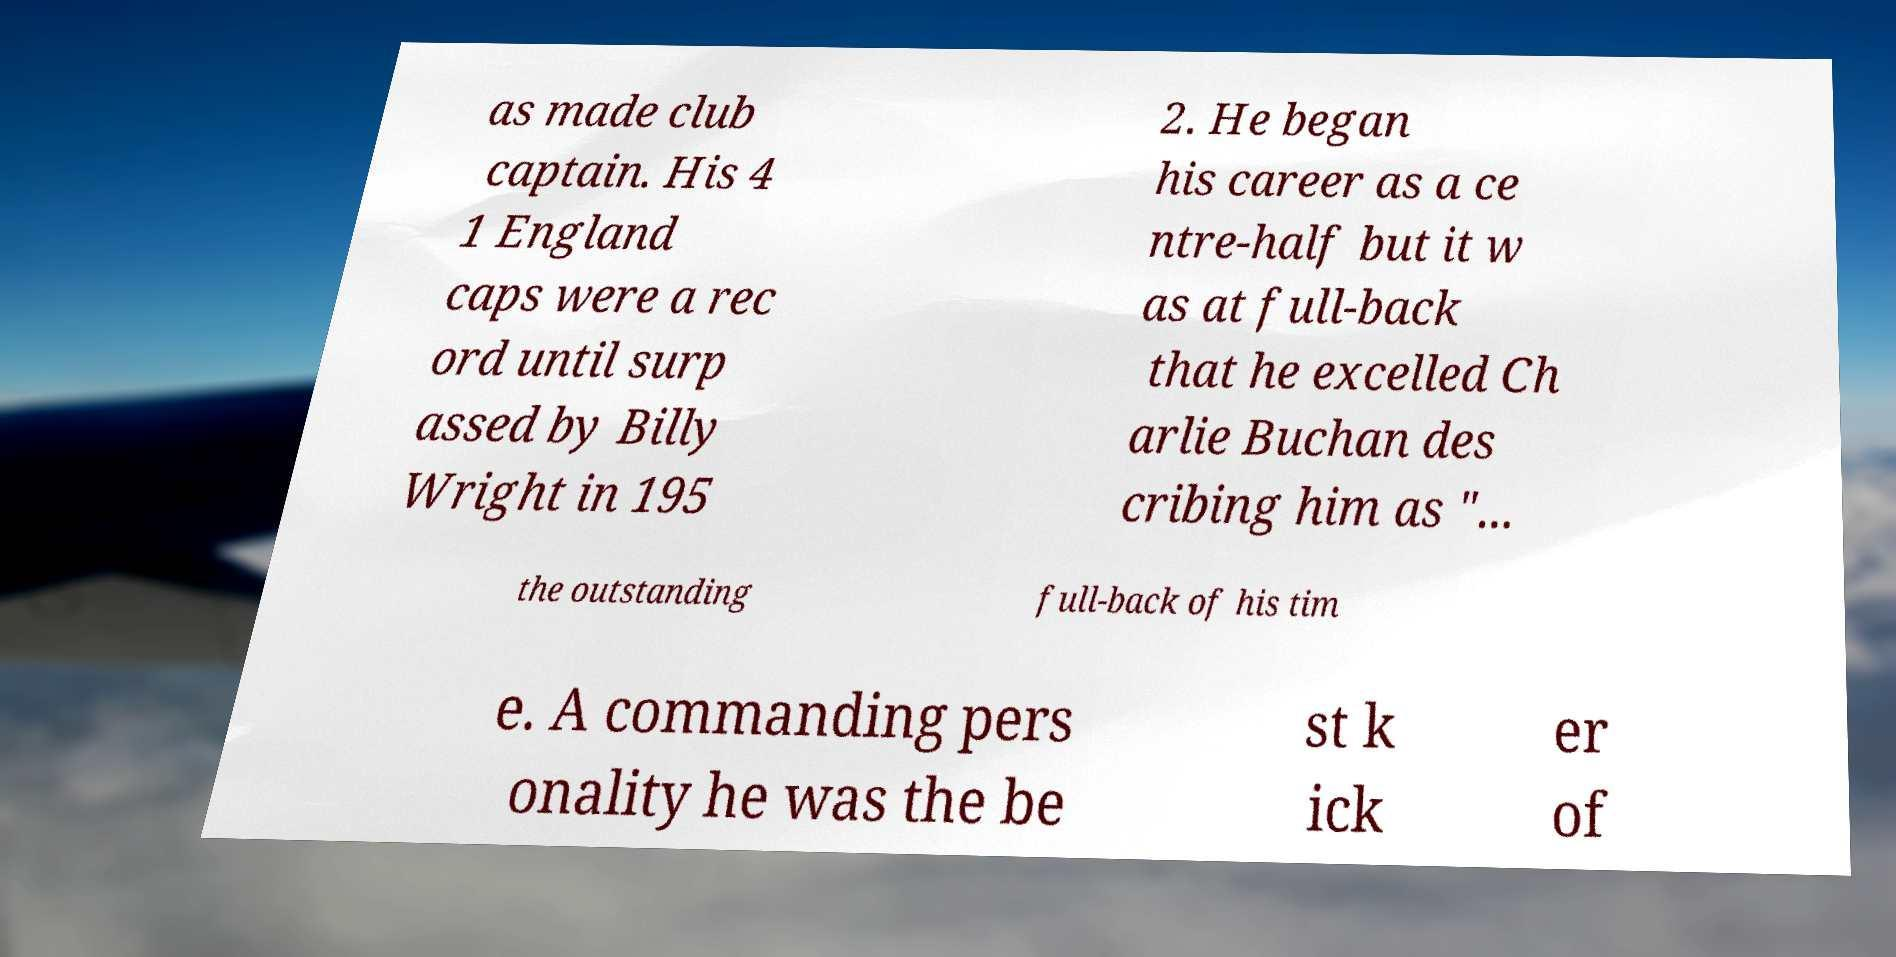Can you read and provide the text displayed in the image?This photo seems to have some interesting text. Can you extract and type it out for me? as made club captain. His 4 1 England caps were a rec ord until surp assed by Billy Wright in 195 2. He began his career as a ce ntre-half but it w as at full-back that he excelled Ch arlie Buchan des cribing him as "... the outstanding full-back of his tim e. A commanding pers onality he was the be st k ick er of 